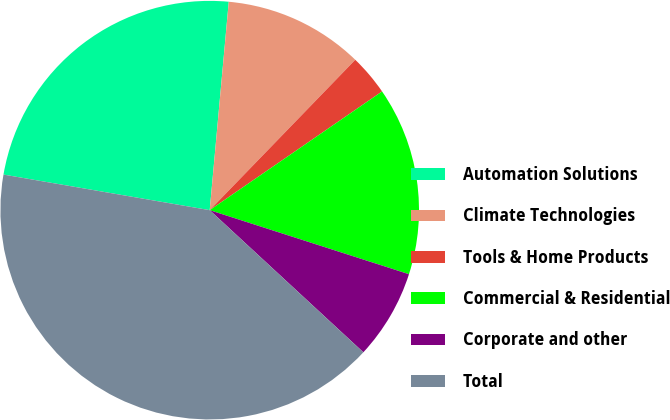Convert chart. <chart><loc_0><loc_0><loc_500><loc_500><pie_chart><fcel>Automation Solutions<fcel>Climate Technologies<fcel>Tools & Home Products<fcel>Commercial & Residential<fcel>Corporate and other<fcel>Total<nl><fcel>23.73%<fcel>10.79%<fcel>3.16%<fcel>14.55%<fcel>6.93%<fcel>40.84%<nl></chart> 